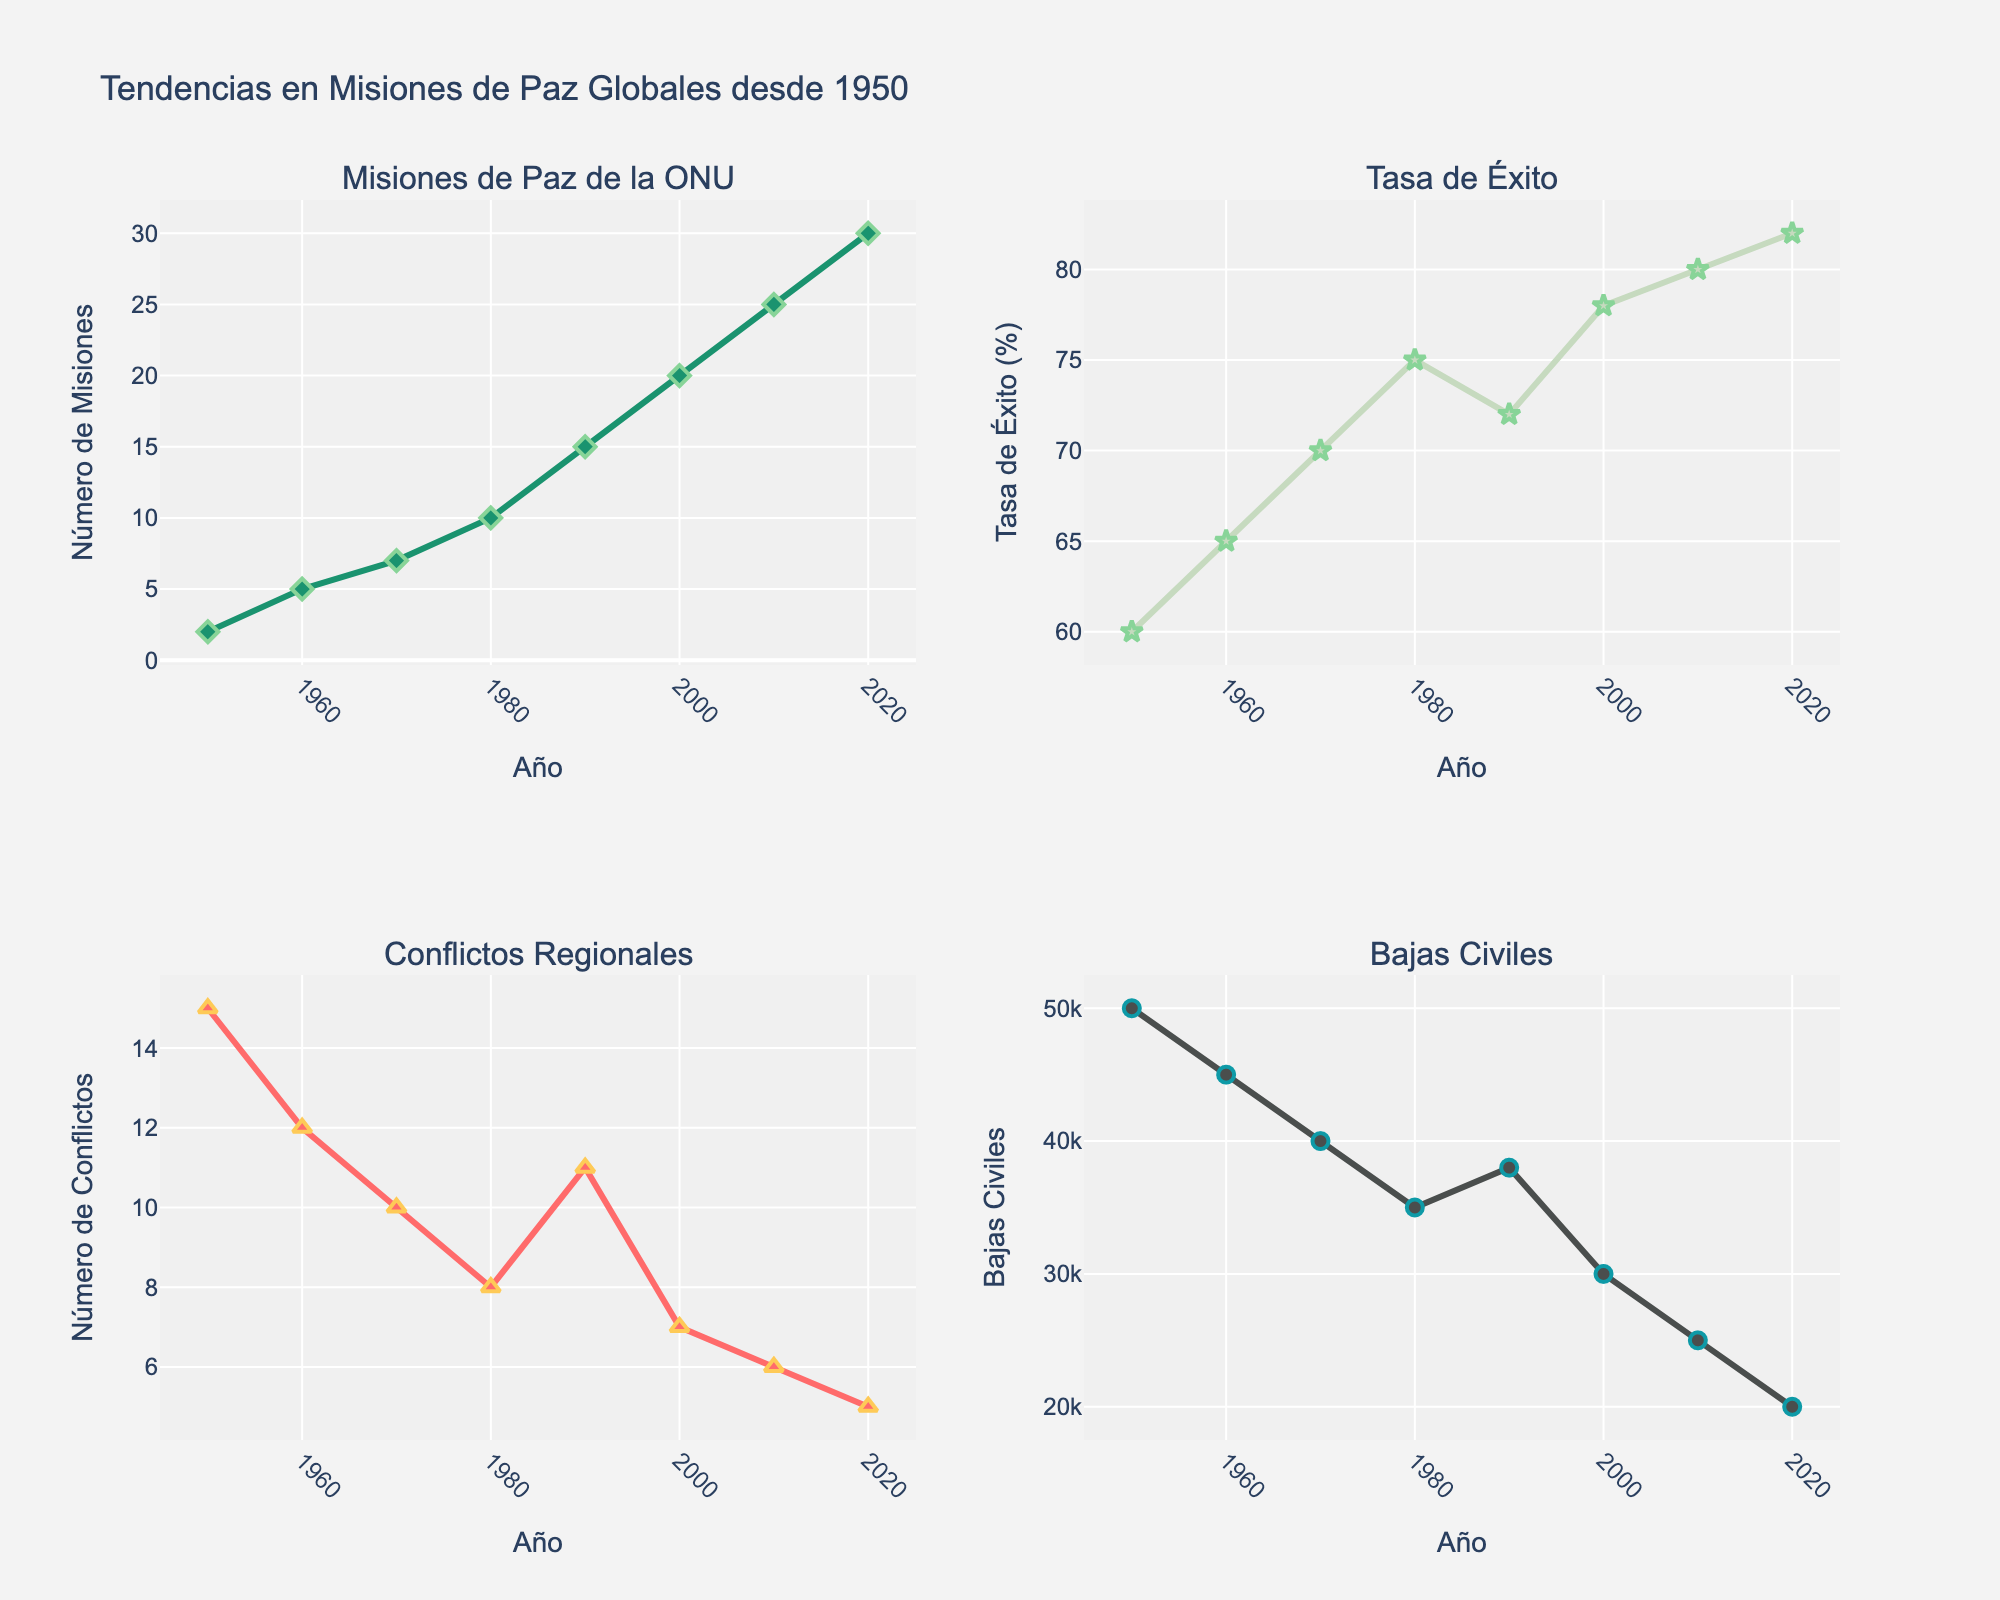¿Cuál es el título de la figura? La figura tiene un título indicado en la parte superior, que resume el contenido visualizado.
Answer: Tendencias en Misiones de Paz Globales desde 1950 ¿Cuál es el valor de la tasa de éxito de las misiones de paz de la ONU en el año 2000? Se observa sobre la línea correspondiente a la tasa de éxito en el gráfico superior derecho con el año 2000 en el eje x, y luego se lee el valor correspondiente en el eje y.
Answer: 78% ¿Cómo ha cambiado el número de misiones de paz de la ONU desde 1950 hasta 2020? Para responder a esta pregunta, se observa la tendencia en la primera gráfica en la primera fila a la izquierda, y se nota que hay un aumento constante en el número de misiones a lo largo de los años.
Answer: Aumentó de 2 a 30 ¿Cuál fue el año con el número más bajo de conflictos regionales? Se identifica en la tercera gráfica de la segunda fila a la izquierda, observando el valor mínimo en el eje y y el año correspondiente en el eje x.
Answer: 2020 ¿Cuántos conflictos regionales había en 1970 y cómo se compara con el año 2000? Primero, se identifican los valores de conflictos regionales en los años 1970 y 2000 en el gráfico correspondiente. Luego, se realiza la comparación.
Answer: En 1970 había 10 conflictos, mientras que en 2000 había 7 ¿Cuál es la relación entre el número de conflictos regionales y las bajas civiles a lo largo del tiempo? Observando la tercera y cuarta gráfica, se observa que a medida que disminuyen los conflictos regionales, también disminuyen las bajas civiles.
Answer: Ambas disminuyen a lo largo del tiempo ¿Cuál es el valor más alto de bajas civiles registrado y en qué año ocurrió? Mirando la cuarta gráfica en la segunda fila a la derecha, se identifica el punto más alto en el eje y, y se lee el año en el eje x correspondiente.
Answer: 50000 en 1950 Compara la tasa de éxito de 1980 con 2010. ¿Cuál es mayor y por cuánto? Se valora la tasa de éxito en ambos años en el gráfico correspondiente, y se calcula la diferencia. En 1980 es 75% y en 2010 es 80%, entonces la diferencia es 80% - 75% = 5%
Answer: 2010 es mayor por 5% ¿Cuál es la tendencia general observada en las bajas civiles desde 1950 hasta 2020? Se observa la tendencia en la cuarta gráfica a lo largo del tiempo y se nota que las bajas civiles disminuyen continuamente desde 1950 hasta 2020.
Answer: Disminuyen continuamente 